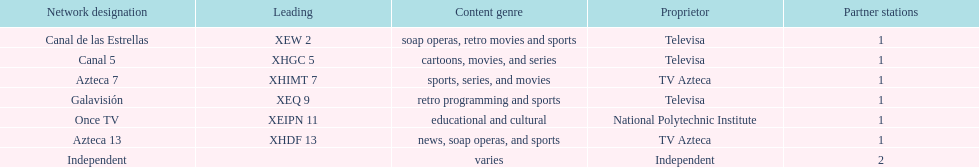Name a station that shows sports but is not televisa. Azteca 7. 